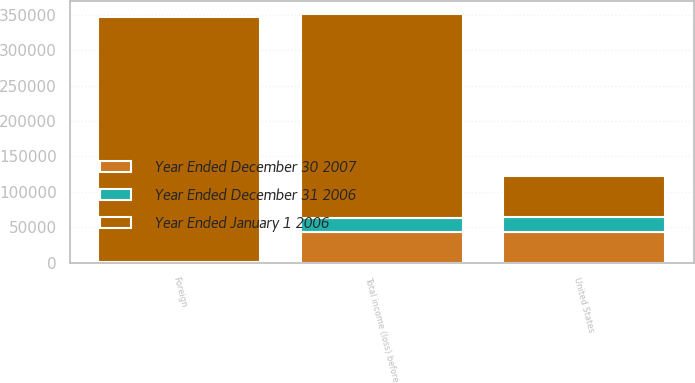<chart> <loc_0><loc_0><loc_500><loc_500><stacked_bar_chart><ecel><fcel>United States<fcel>Foreign<fcel>Total income (loss) before<nl><fcel>Year Ended January 1 2006<fcel>58445<fcel>347230<fcel>288785<nl><fcel>Year Ended December 30 2007<fcel>42612<fcel>8<fcel>42620<nl><fcel>Year Ended December 31 2006<fcel>21365<fcel>654<fcel>20711<nl></chart> 